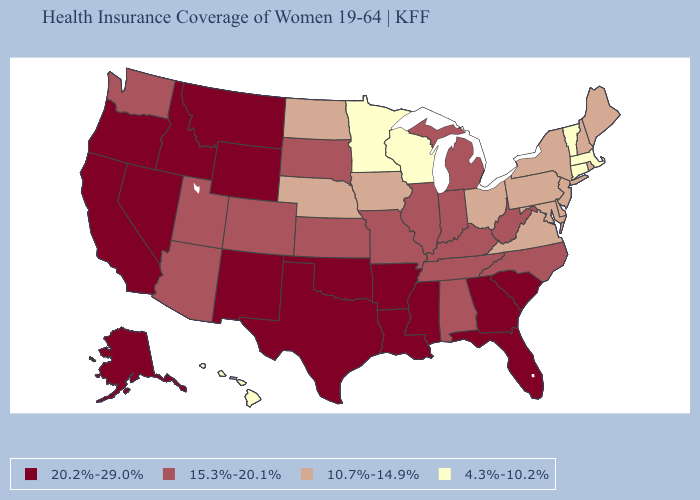Among the states that border South Carolina , does North Carolina have the highest value?
Be succinct. No. Name the states that have a value in the range 4.3%-10.2%?
Be succinct. Connecticut, Hawaii, Massachusetts, Minnesota, Vermont, Wisconsin. Is the legend a continuous bar?
Concise answer only. No. Name the states that have a value in the range 15.3%-20.1%?
Be succinct. Alabama, Arizona, Colorado, Illinois, Indiana, Kansas, Kentucky, Michigan, Missouri, North Carolina, South Dakota, Tennessee, Utah, Washington, West Virginia. Does Florida have the lowest value in the South?
Short answer required. No. Does Washington have the lowest value in the West?
Be succinct. No. Name the states that have a value in the range 10.7%-14.9%?
Give a very brief answer. Delaware, Iowa, Maine, Maryland, Nebraska, New Hampshire, New Jersey, New York, North Dakota, Ohio, Pennsylvania, Rhode Island, Virginia. How many symbols are there in the legend?
Quick response, please. 4. Name the states that have a value in the range 20.2%-29.0%?
Give a very brief answer. Alaska, Arkansas, California, Florida, Georgia, Idaho, Louisiana, Mississippi, Montana, Nevada, New Mexico, Oklahoma, Oregon, South Carolina, Texas, Wyoming. Which states hav the highest value in the West?
Quick response, please. Alaska, California, Idaho, Montana, Nevada, New Mexico, Oregon, Wyoming. Name the states that have a value in the range 20.2%-29.0%?
Be succinct. Alaska, Arkansas, California, Florida, Georgia, Idaho, Louisiana, Mississippi, Montana, Nevada, New Mexico, Oklahoma, Oregon, South Carolina, Texas, Wyoming. What is the lowest value in the MidWest?
Write a very short answer. 4.3%-10.2%. Name the states that have a value in the range 10.7%-14.9%?
Keep it brief. Delaware, Iowa, Maine, Maryland, Nebraska, New Hampshire, New Jersey, New York, North Dakota, Ohio, Pennsylvania, Rhode Island, Virginia. What is the value of Louisiana?
Give a very brief answer. 20.2%-29.0%. 